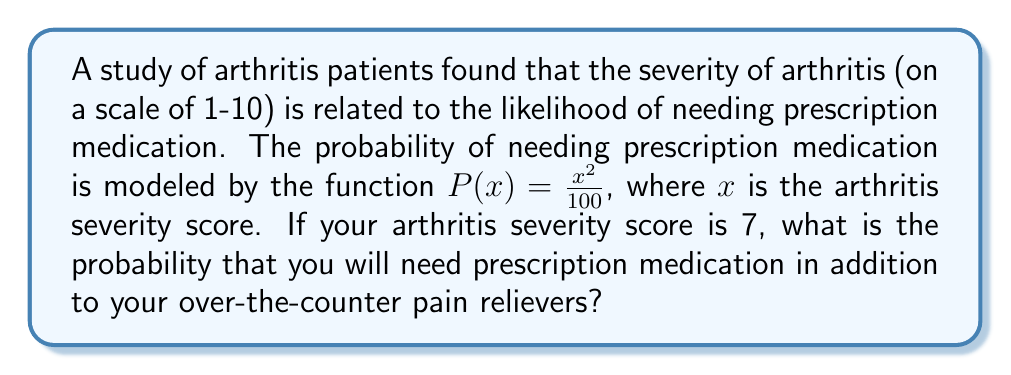Help me with this question. To solve this problem, we need to follow these steps:

1. Understand the given function:
   The probability of needing prescription medication is given by $P(x) = \frac{x^2}{100}$, where $x$ is the arthritis severity score.

2. Identify the arthritis severity score:
   In this case, your arthritis severity score is 7.

3. Substitute the severity score into the function:
   $P(7) = \frac{7^2}{100}$

4. Calculate the result:
   $P(7) = \frac{49}{100} = 0.49$

Therefore, the probability of needing prescription medication with an arthritis severity score of 7 is 0.49 or 49%.
Answer: $P(7) = 0.49$ or 49% 